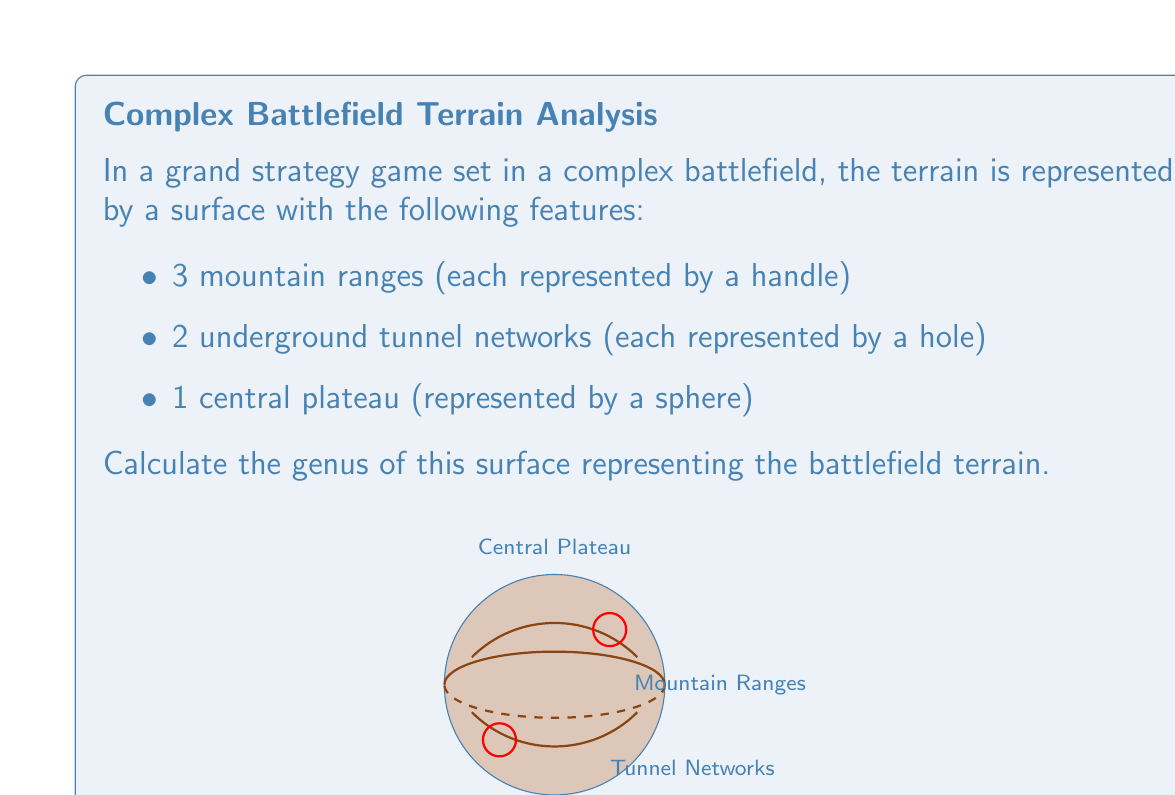Can you answer this question? To calculate the genus of this surface, we need to understand the topological concept of genus and how it relates to the features of our battlefield terrain. The genus of a surface is the maximum number of cuts along non-intersecting closed simple curves without rendering the resultant manifold disconnected.

Let's break down the problem step-by-step:

1) We start with a sphere (the central plateau), which has a genus of 0.

2) Each handle (mountain range) adds 1 to the genus. We have 3 mountain ranges, so:
   Contribution from handles = 3

3) Each hole (underground tunnel network) also adds 1 to the genus. We have 2 tunnel networks, so:
   Contribution from holes = 2

4) The genus of the entire surface is the sum of these contributions:
   $$g = g_{sphere} + g_{handles} + g_{holes}$$
   $$g = 0 + 3 + 2 = 5$$

In topological terms, this surface is homeomorphic to a sphere with 5 handles, which is equivalent to a surface of genus 5.

This complex representation of the battlefield terrain allows for strategic depth in the game, with mountain ranges providing defensive positions and underground tunnels offering secret passage options, fitting well with the persona's preference for complex strategy games.
Answer: 5 